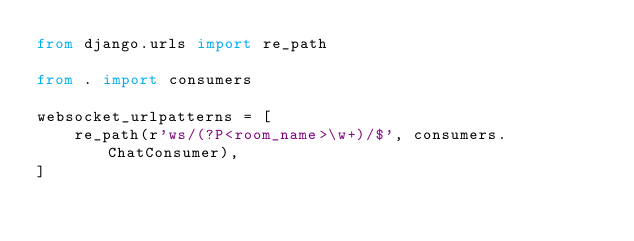<code> <loc_0><loc_0><loc_500><loc_500><_Python_>from django.urls import re_path

from . import consumers

websocket_urlpatterns = [
    re_path(r'ws/(?P<room_name>\w+)/$', consumers.ChatConsumer),
]</code> 